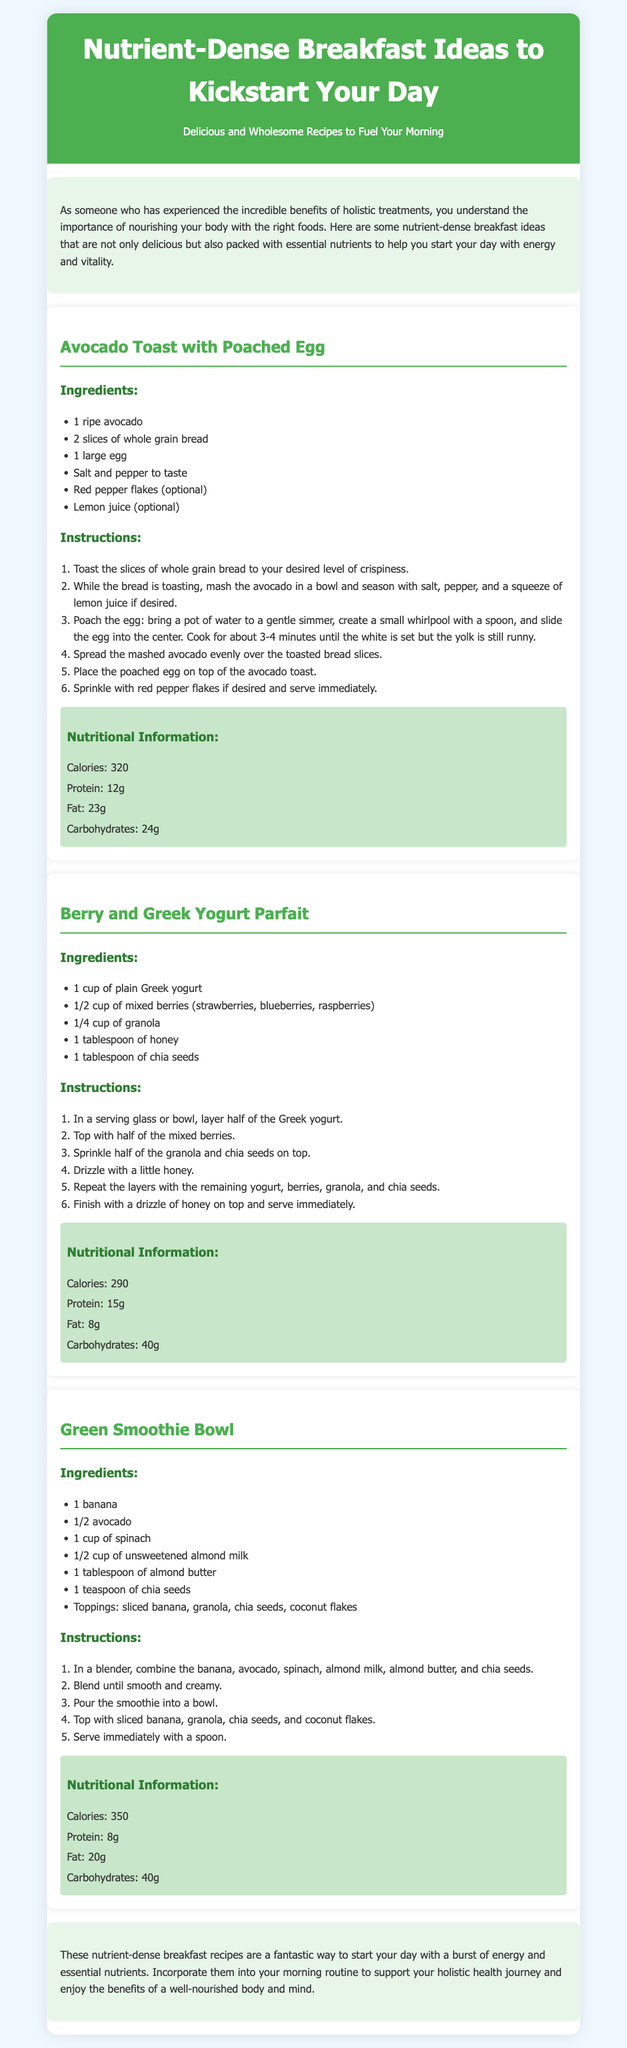What is the first recipe featured? The first recipe listed in the document is "Avocado Toast with Poached Egg."
Answer: Avocado Toast with Poached Egg How many slices of bread are needed for the Avocado Toast? The recipe for Avocado Toast requires 2 slices of whole grain bread.
Answer: 2 slices What is the main ingredient in the Berry and Greek Yogurt Parfait? The key ingredient of the Berry and Greek Yogurt Parfait is plain Greek yogurt.
Answer: Greek yogurt What nutrient is highest in the Avocado Toast recipe? The highest nutrient in the Avocado Toast is fat, which is 23g.
Answer: 23g How many tablespoons of honey are used in the Berry and Greek Yogurt Parfait? The recipe specifies using 1 tablespoon of honey.
Answer: 1 tablespoon What topping options are suggested for the Green Smoothie Bowl? The suggested toppings include sliced banana, granola, chia seeds, and coconut flakes.
Answer: Sliced banana, granola, chia seeds, coconut flakes What is the total calorie content of the Green Smoothie Bowl? The calorie content for the Green Smoothie Bowl is listed as 350 calories.
Answer: 350 calories What dietary benefit is mentioned in the conclusion of the document? The conclusion states that these recipes support a holistic health journey.
Answer: Holistic health journey 